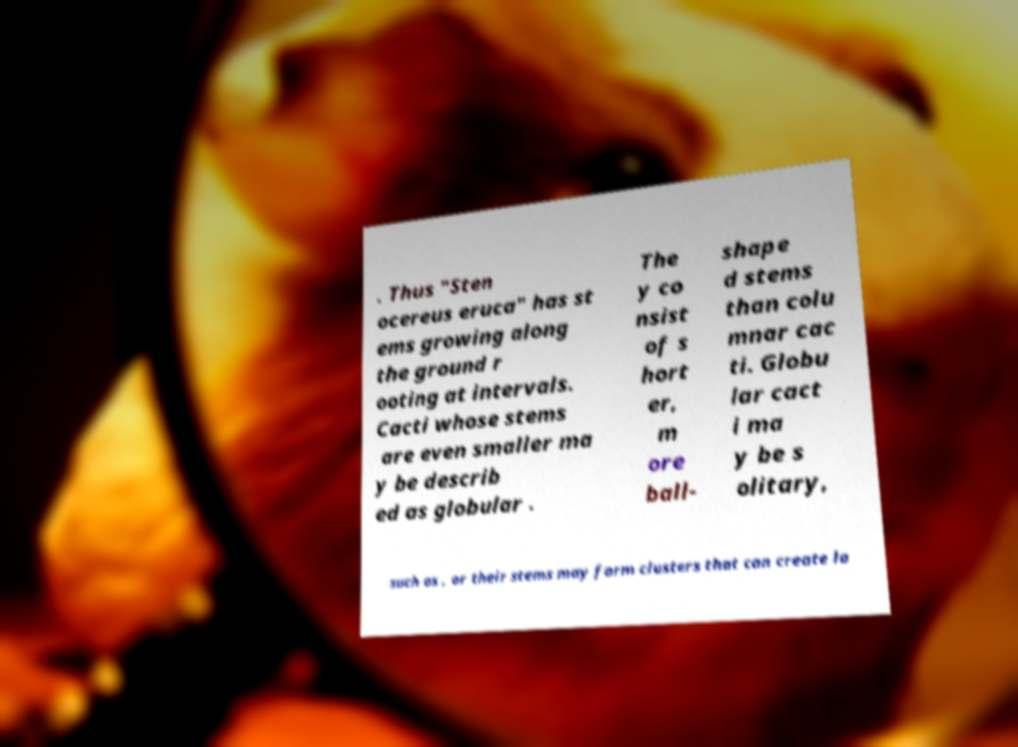Could you extract and type out the text from this image? . Thus "Sten ocereus eruca" has st ems growing along the ground r ooting at intervals. Cacti whose stems are even smaller ma y be describ ed as globular . The y co nsist of s hort er, m ore ball- shape d stems than colu mnar cac ti. Globu lar cact i ma y be s olitary, such as , or their stems may form clusters that can create la 